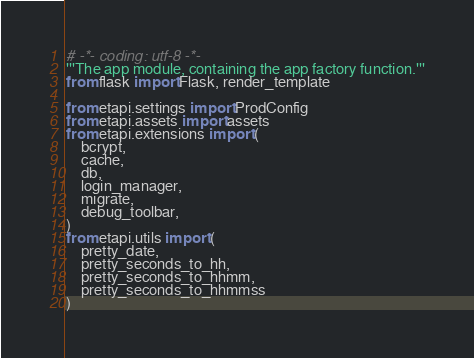<code> <loc_0><loc_0><loc_500><loc_500><_Python_># -*- coding: utf-8 -*-
'''The app module, containing the app factory function.'''
from flask import Flask, render_template

from etapi.settings import ProdConfig
from etapi.assets import assets
from etapi.extensions import (
    bcrypt,
    cache,
    db,
    login_manager,
    migrate,
    debug_toolbar,
)
from etapi.utils import (
    pretty_date,
    pretty_seconds_to_hh,
    pretty_seconds_to_hhmm,
    pretty_seconds_to_hhmmss
)
</code> 